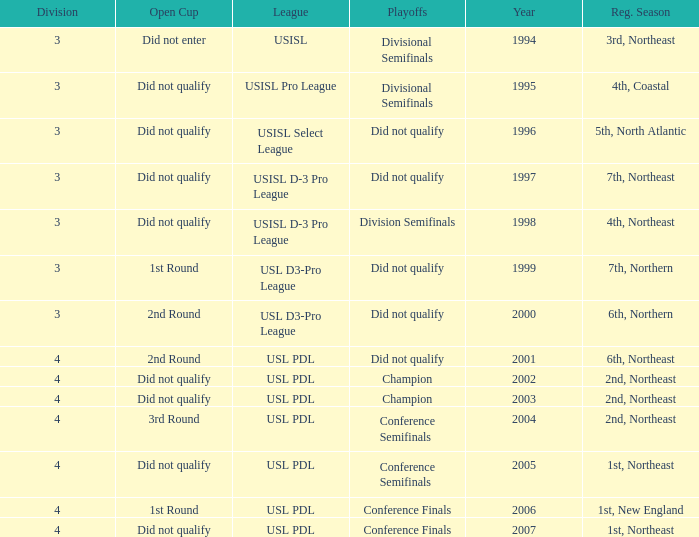Name the playoffs for  usisl select league Did not qualify. 